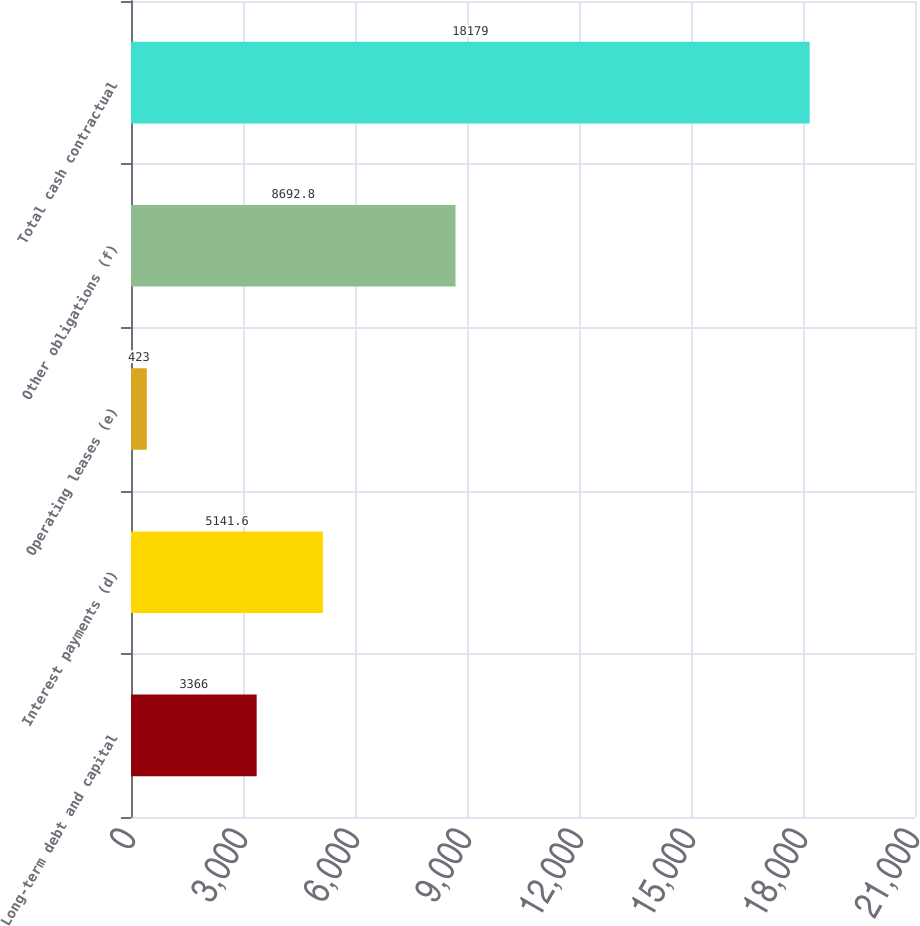<chart> <loc_0><loc_0><loc_500><loc_500><bar_chart><fcel>Long-term debt and capital<fcel>Interest payments (d)<fcel>Operating leases (e)<fcel>Other obligations (f)<fcel>Total cash contractual<nl><fcel>3366<fcel>5141.6<fcel>423<fcel>8692.8<fcel>18179<nl></chart> 